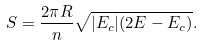<formula> <loc_0><loc_0><loc_500><loc_500>S = \frac { 2 \pi R } { n } \sqrt { | E _ { c } | ( 2 E - E _ { c } ) } .</formula> 